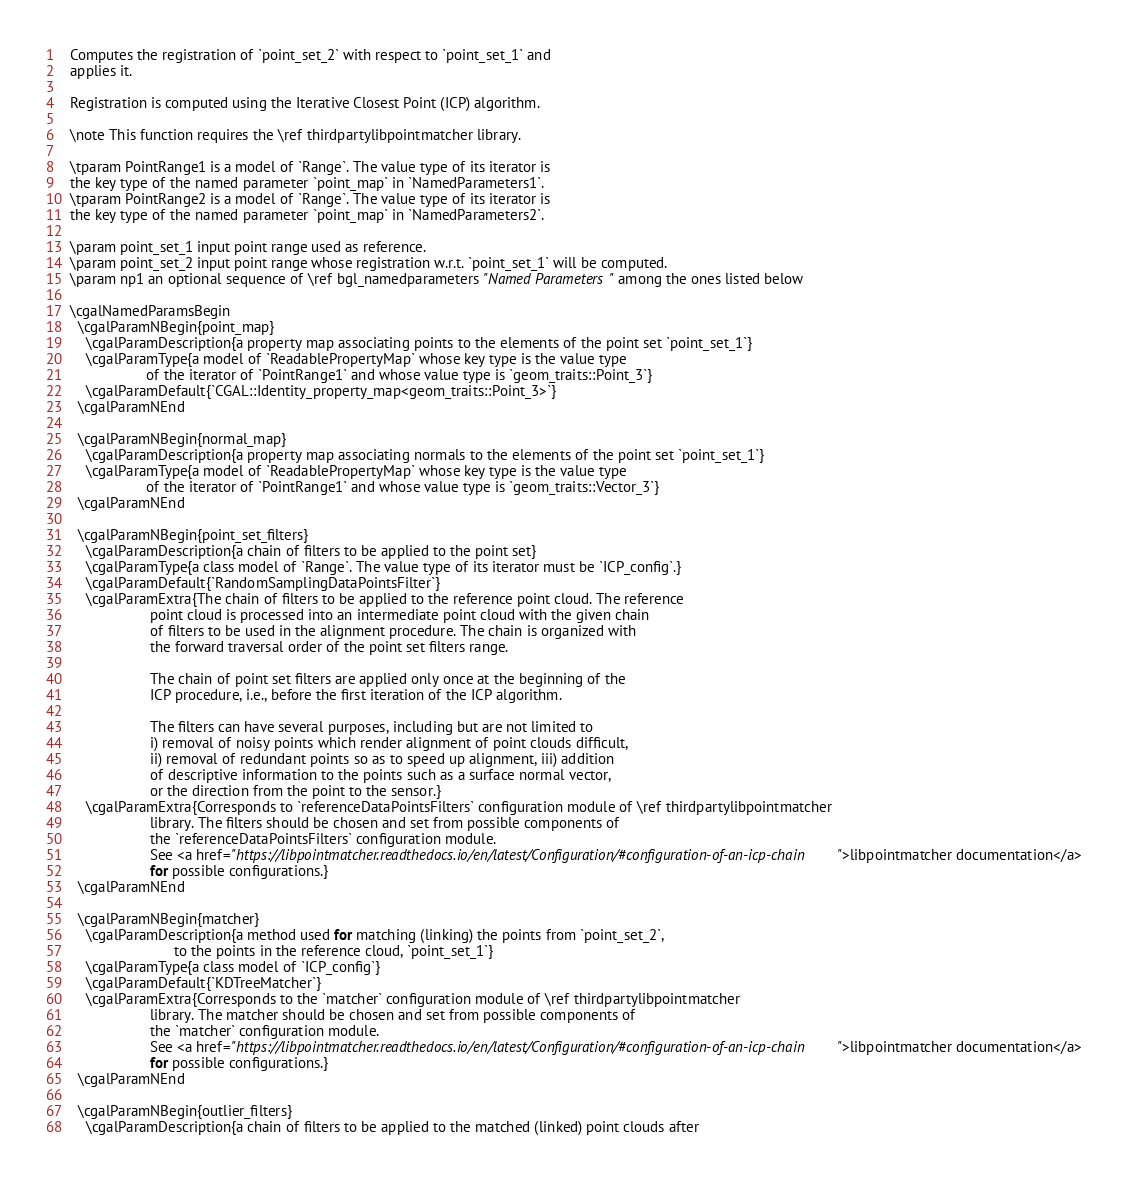<code> <loc_0><loc_0><loc_500><loc_500><_C_>
   Computes the registration of `point_set_2` with respect to `point_set_1` and
   applies it.

   Registration is computed using the Iterative Closest Point (ICP) algorithm.

   \note This function requires the \ref thirdpartylibpointmatcher library.

   \tparam PointRange1 is a model of `Range`. The value type of its iterator is
   the key type of the named parameter `point_map` in `NamedParameters1`.
   \tparam PointRange2 is a model of `Range`. The value type of its iterator is
   the key type of the named parameter `point_map` in `NamedParameters2`.

   \param point_set_1 input point range used as reference.
   \param point_set_2 input point range whose registration w.r.t. `point_set_1` will be computed.
   \param np1 an optional sequence of \ref bgl_namedparameters "Named Parameters" among the ones listed below

   \cgalNamedParamsBegin
     \cgalParamNBegin{point_map}
       \cgalParamDescription{a property map associating points to the elements of the point set `point_set_1`}
       \cgalParamType{a model of `ReadablePropertyMap` whose key type is the value type
                      of the iterator of `PointRange1` and whose value type is `geom_traits::Point_3`}
       \cgalParamDefault{`CGAL::Identity_property_map<geom_traits::Point_3>`}
     \cgalParamNEnd

     \cgalParamNBegin{normal_map}
       \cgalParamDescription{a property map associating normals to the elements of the point set `point_set_1`}
       \cgalParamType{a model of `ReadablePropertyMap` whose key type is the value type
                      of the iterator of `PointRange1` and whose value type is `geom_traits::Vector_3`}
     \cgalParamNEnd

     \cgalParamNBegin{point_set_filters}
       \cgalParamDescription{a chain of filters to be applied to the point set}
       \cgalParamType{a class model of `Range`. The value type of its iterator must be `ICP_config`.}
       \cgalParamDefault{`RandomSamplingDataPointsFilter`}
       \cgalParamExtra{The chain of filters to be applied to the reference point cloud. The reference
                       point cloud is processed into an intermediate point cloud with the given chain
                       of filters to be used in the alignment procedure. The chain is organized with
                       the forward traversal order of the point set filters range.

                       The chain of point set filters are applied only once at the beginning of the
                       ICP procedure, i.e., before the first iteration of the ICP algorithm.

                       The filters can have several purposes, including but are not limited to
                       i) removal of noisy points which render alignment of point clouds difficult,
                       ii) removal of redundant points so as to speed up alignment, iii) addition
                       of descriptive information to the points such as a surface normal vector,
                       or the direction from the point to the sensor.}
       \cgalParamExtra{Corresponds to `referenceDataPointsFilters` configuration module of \ref thirdpartylibpointmatcher
                       library. The filters should be chosen and set from possible components of
                       the `referenceDataPointsFilters` configuration module.
                       See <a href="https://libpointmatcher.readthedocs.io/en/latest/Configuration/#configuration-of-an-icp-chain">libpointmatcher documentation</a>
                       for possible configurations.}
     \cgalParamNEnd

     \cgalParamNBegin{matcher}
       \cgalParamDescription{a method used for matching (linking) the points from `point_set_2`,
                             to the points in the reference cloud, `point_set_1`}
       \cgalParamType{a class model of `ICP_config`}
       \cgalParamDefault{`KDTreeMatcher`}
       \cgalParamExtra{Corresponds to the `matcher` configuration module of \ref thirdpartylibpointmatcher
                       library. The matcher should be chosen and set from possible components of
                       the `matcher` configuration module.
                       See <a href="https://libpointmatcher.readthedocs.io/en/latest/Configuration/#configuration-of-an-icp-chain">libpointmatcher documentation</a>
                       for possible configurations.}
     \cgalParamNEnd

     \cgalParamNBegin{outlier_filters}
       \cgalParamDescription{a chain of filters to be applied to the matched (linked) point clouds after</code> 